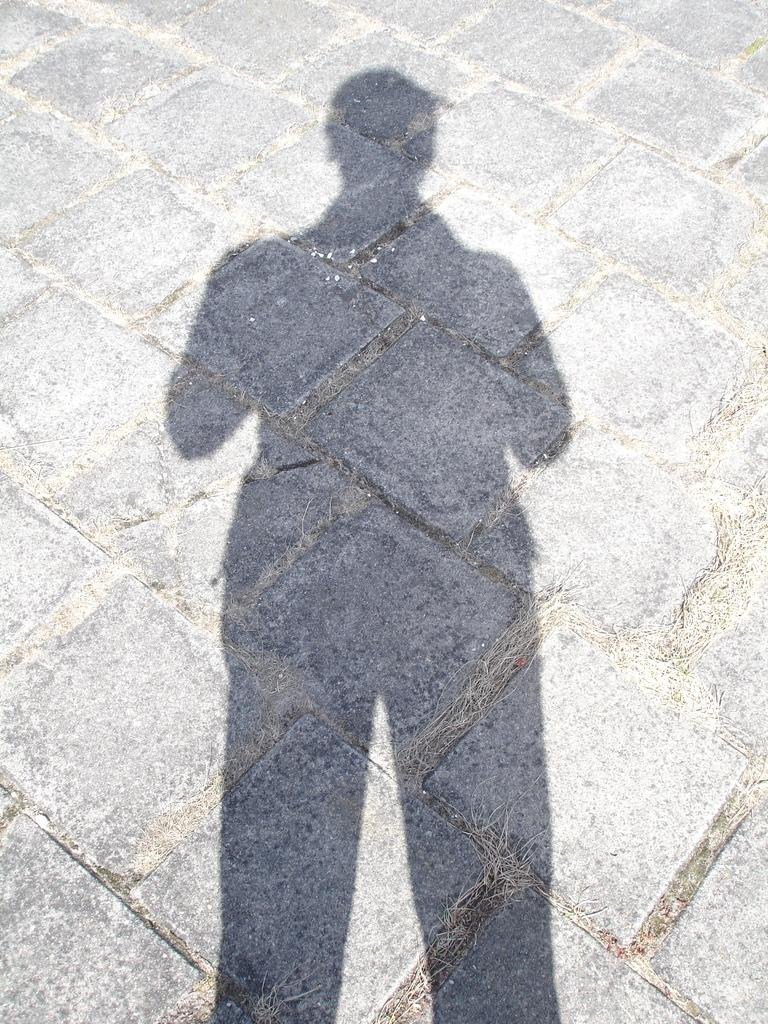What can be seen in the image that is not a solid object? There is a shadow of a person in the image. Where is the shadow located in the image? The shadow is on a path. What type of spoon can be seen in the shadow of the person in the image? There is no spoon present in the image; it only shows a shadow of a person on a path. 